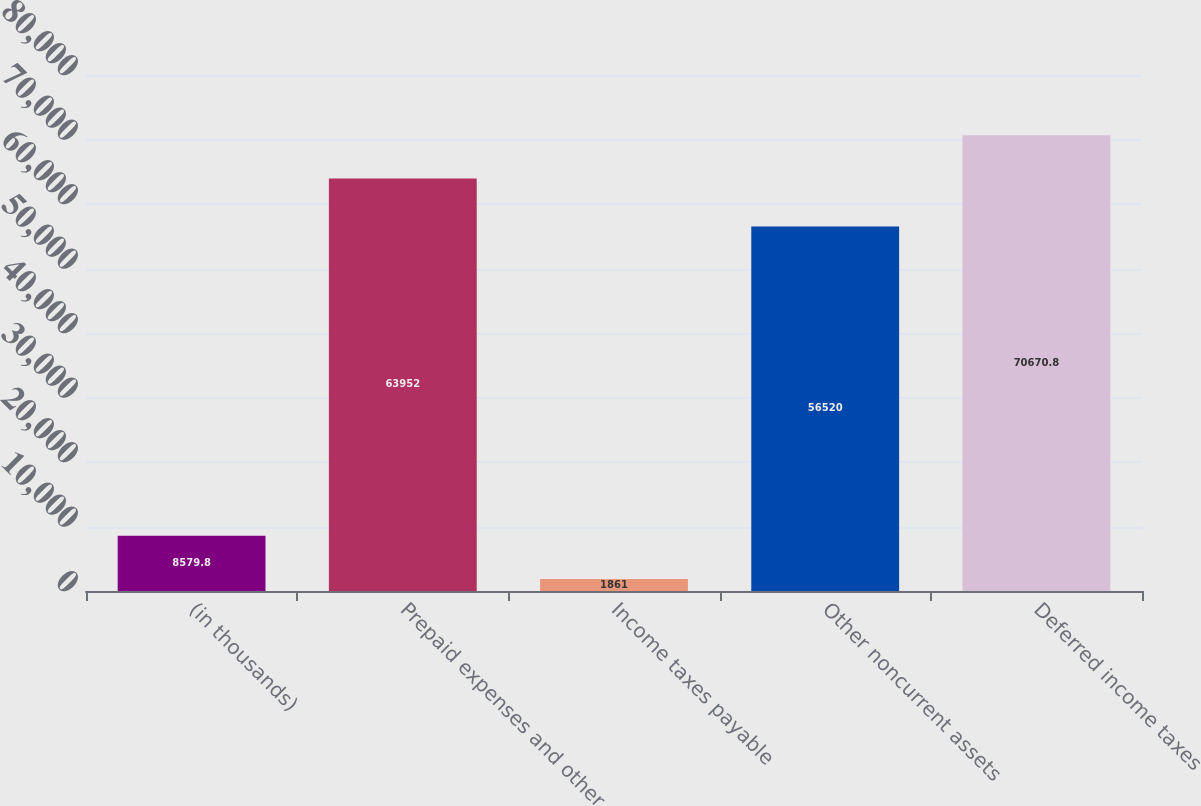Convert chart to OTSL. <chart><loc_0><loc_0><loc_500><loc_500><bar_chart><fcel>(in thousands)<fcel>Prepaid expenses and other<fcel>Income taxes payable<fcel>Other noncurrent assets<fcel>Deferred income taxes<nl><fcel>8579.8<fcel>63952<fcel>1861<fcel>56520<fcel>70670.8<nl></chart> 